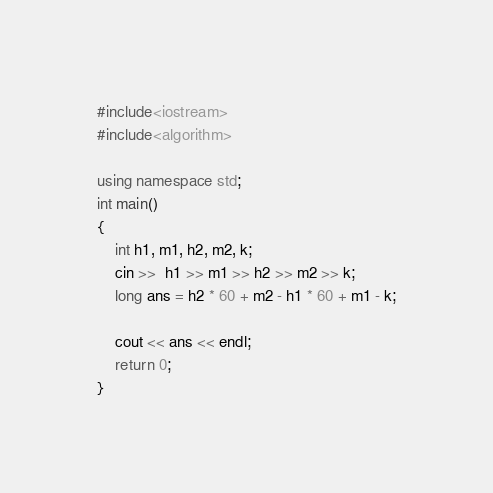<code> <loc_0><loc_0><loc_500><loc_500><_C++_>#include<iostream>
#include<algorithm>

using namespace std;
int main()
{
  	int h1, m1, h2, m2, k;
  	cin >>  h1 >> m1 >> h2 >> m2 >> k;
    long ans = h2 * 60 + m2 - h1 * 60 + m1 - k;

	cout << ans << endl;
	return 0;
}
</code> 